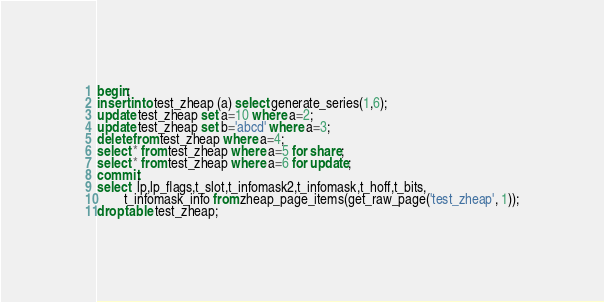Convert code to text. <code><loc_0><loc_0><loc_500><loc_500><_SQL_>begin;
insert into test_zheap (a) select generate_series(1,6);
update test_zheap set a=10 where a=2;
update test_zheap set b='abcd' where a=3;
delete from test_zheap where a=4;
select * from test_zheap where a=5 for share;
select * from test_zheap where a=6 for update;
commit;
select  lp,lp_flags,t_slot,t_infomask2,t_infomask,t_hoff,t_bits,
		t_infomask_info from zheap_page_items(get_raw_page('test_zheap', 1));
drop table test_zheap;
</code> 